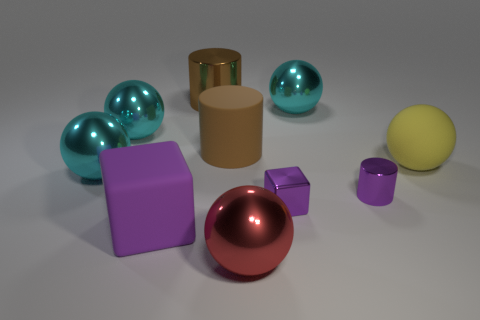Subtract all red cubes. How many cyan balls are left? 3 Subtract all red spheres. How many spheres are left? 4 Subtract all yellow spheres. How many spheres are left? 4 Subtract all yellow balls. Subtract all yellow cylinders. How many balls are left? 4 Add 7 large red objects. How many large red objects are left? 8 Add 1 small yellow spheres. How many small yellow spheres exist? 1 Subtract 0 blue cylinders. How many objects are left? 10 Subtract all blocks. How many objects are left? 8 Subtract all big red shiny objects. Subtract all large yellow rubber spheres. How many objects are left? 8 